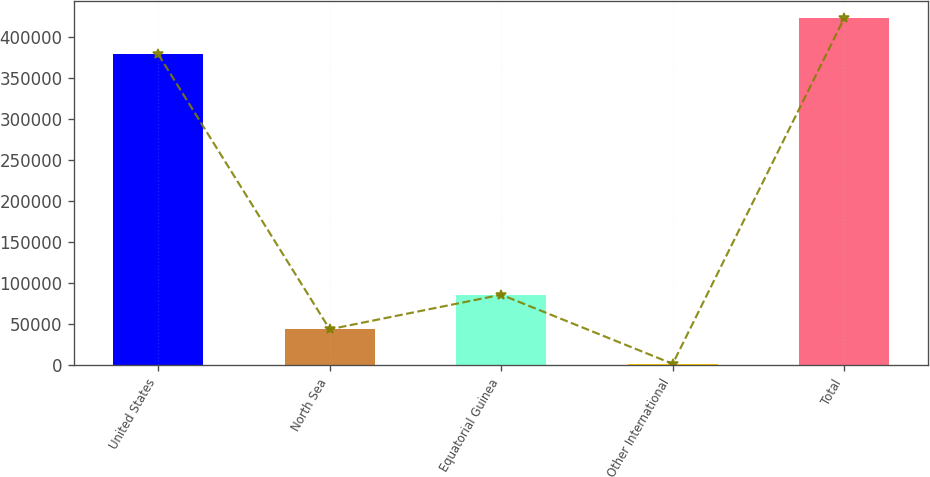Convert chart. <chart><loc_0><loc_0><loc_500><loc_500><bar_chart><fcel>United States<fcel>North Sea<fcel>Equatorial Guinea<fcel>Other International<fcel>Total<nl><fcel>378475<fcel>43730.3<fcel>85809.6<fcel>1651<fcel>422444<nl></chart> 